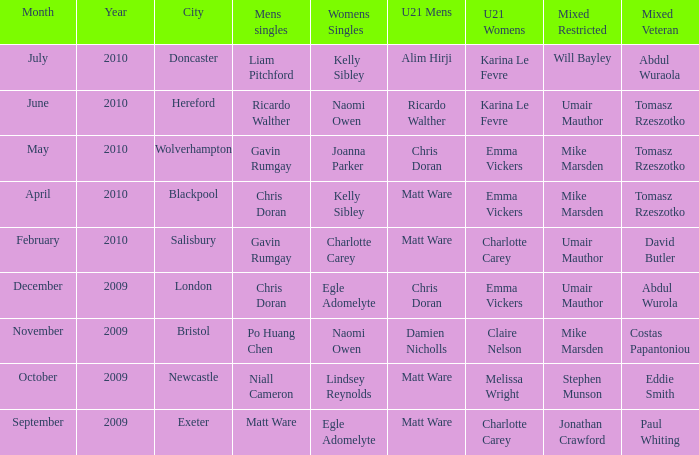When Paul Whiting won the mixed veteran, who won the mixed restricted? Jonathan Crawford. 